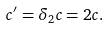Convert formula to latex. <formula><loc_0><loc_0><loc_500><loc_500>c ^ { \prime } = \delta _ { 2 } c = 2 c .</formula> 